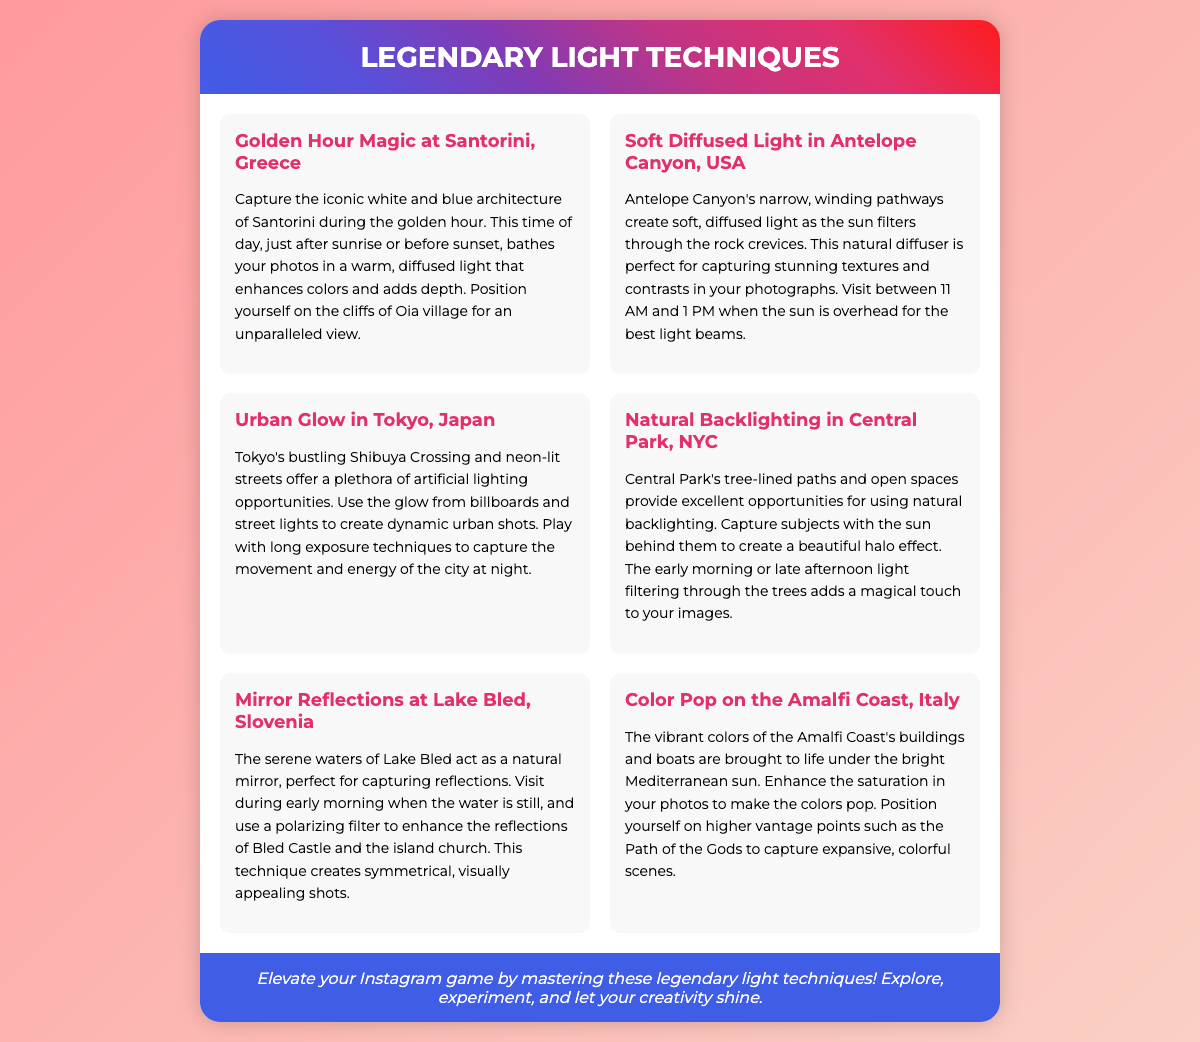What is the title of the poster? The title of the poster is presented prominently at the top of the document.
Answer: Legendary Light Techniques Which location is known for its golden hour magic? The document specifically mentions this location associated with the golden hour technique.
Answer: Santorini, Greece What is the ideal time to visit Antelope Canyon for the best light? The document provides specific time recommendations for optimal lighting conditions in this location.
Answer: 11 AM to 1 PM What technique is suggested for capturing urban shots in Tokyo? The document mentions specific photography techniques that can be used in this vibrant city environment.
Answer: Long exposure Which location features mirror reflections in its photography tips? The document indicates a specific location that is famous for its reflective waters ideal for photography.
Answer: Lake Bled, Slovenia What effect can be achieved by using natural backlighting in Central Park? The document discusses the visual outcome of a specific technique when photographing in this location.
Answer: Halo effect What should you use to enhance reflections at Lake Bled? The document recommends a specific tool to improve the quality of reflections in photographs at this location.
Answer: Polarizing filter Which coastal location is noted for its vibrant colors? The document mentions a specific coast that is recognized for colorful photography.
Answer: Amalfi Coast, Italy 